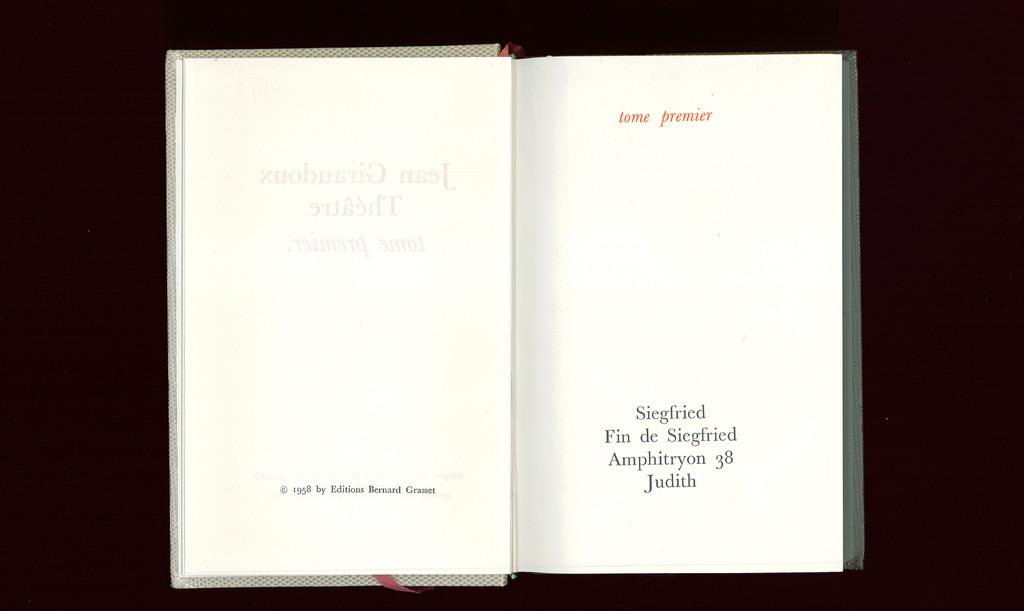<image>
Offer a succinct explanation of the picture presented. a book, copywritten in 1958 is open to an early page 